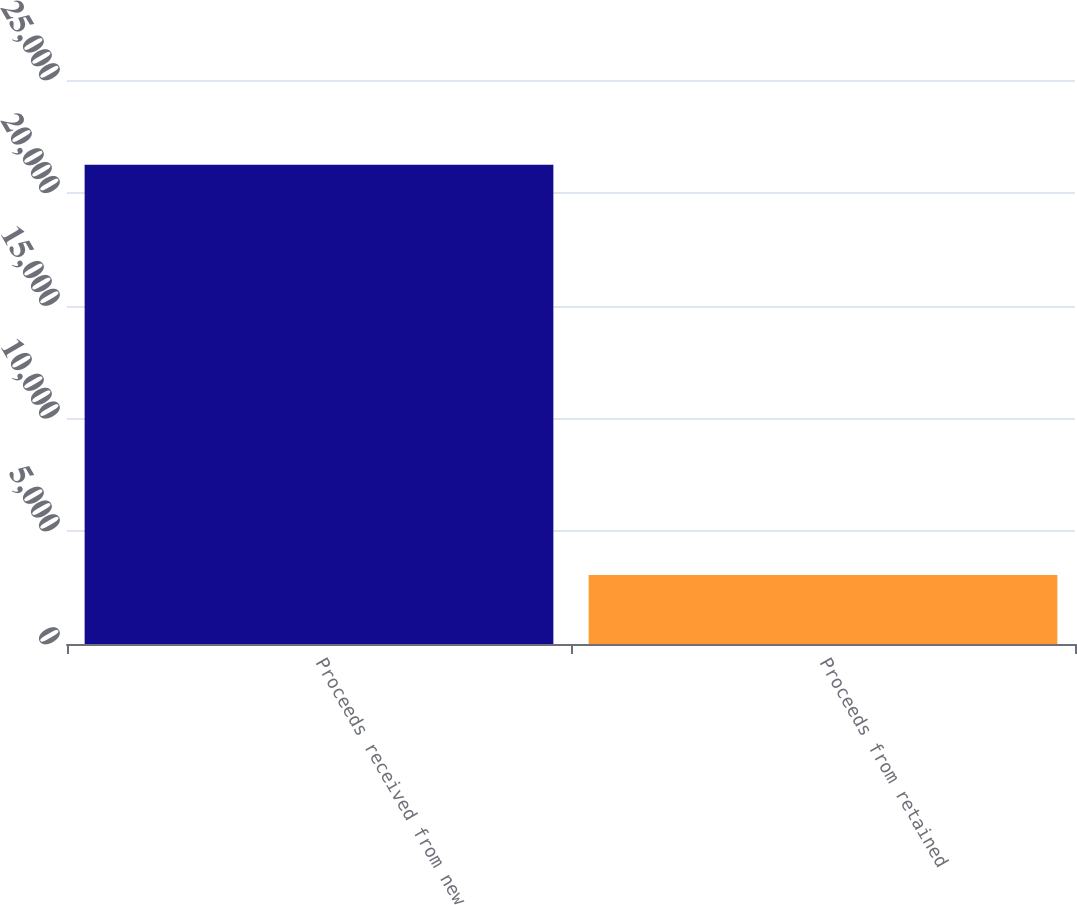<chart> <loc_0><loc_0><loc_500><loc_500><bar_chart><fcel>Proceeds received from new<fcel>Proceeds from retained<nl><fcel>21243<fcel>3062<nl></chart> 